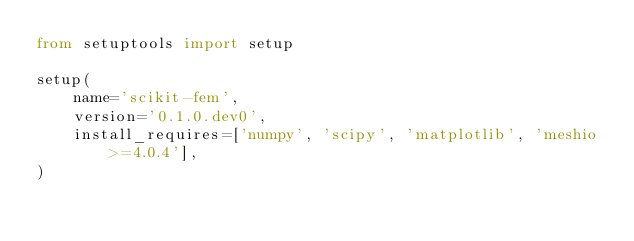<code> <loc_0><loc_0><loc_500><loc_500><_Python_>from setuptools import setup

setup(
    name='scikit-fem',
    version='0.1.0.dev0',
    install_requires=['numpy', 'scipy', 'matplotlib', 'meshio>=4.0.4'],
)
</code> 